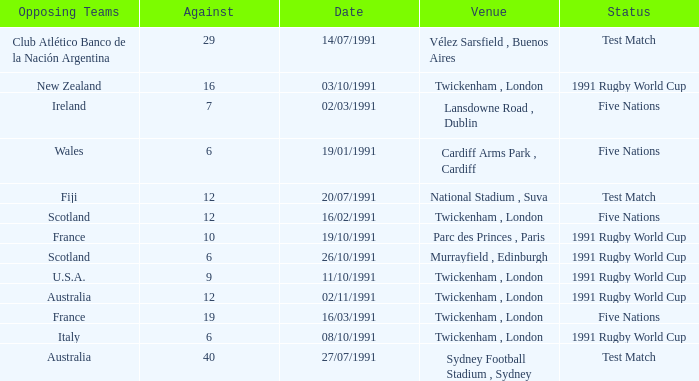What is Date, when Opposing Teams is "Australia", and when Venue is "Twickenham , London"? 02/11/1991. 